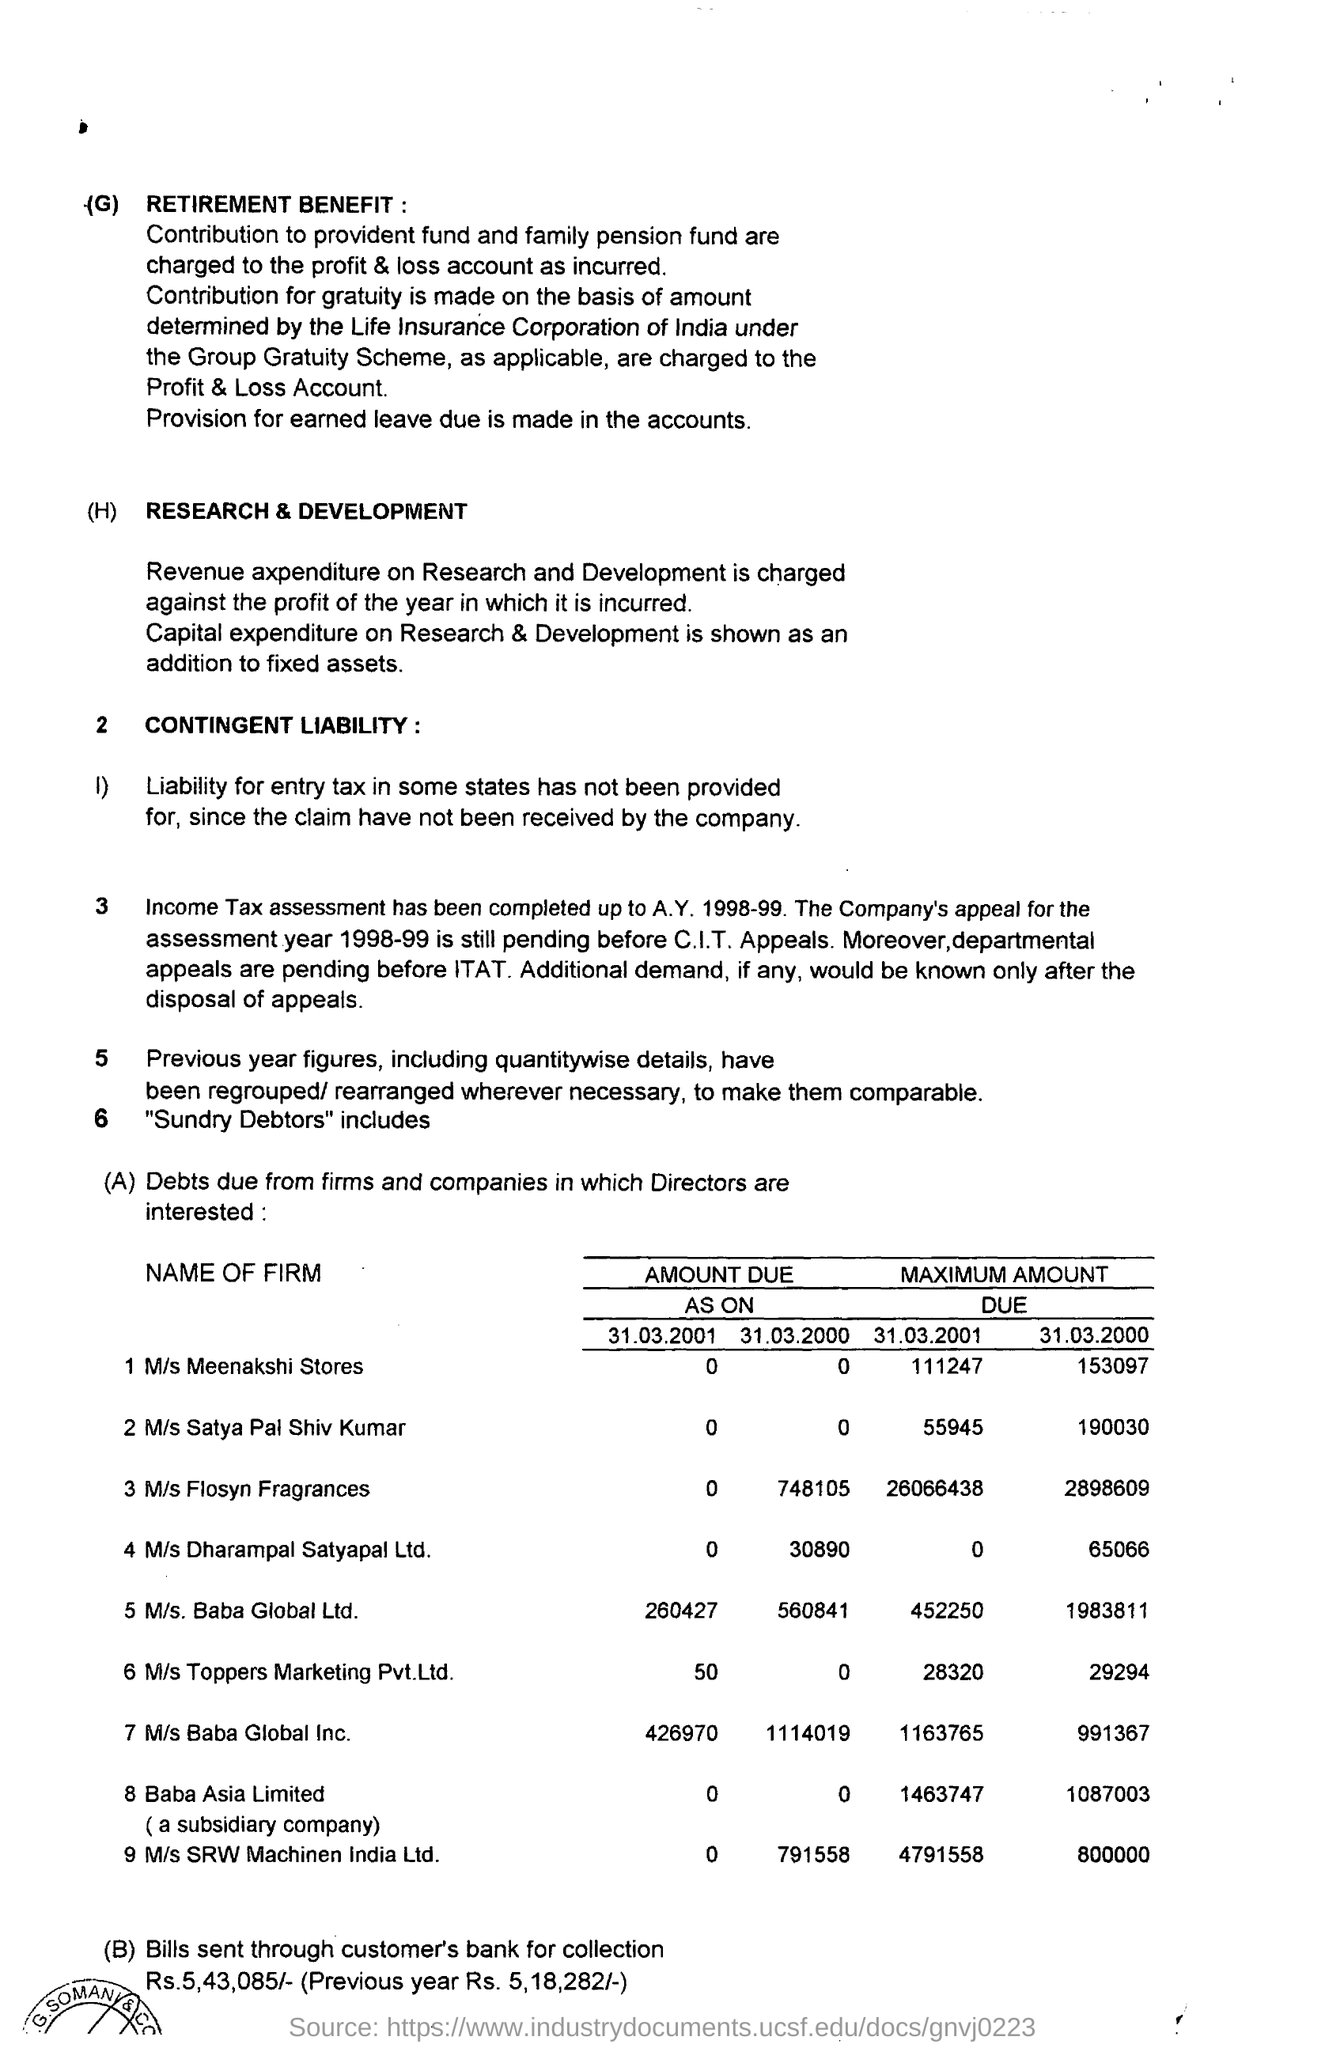Highlight a few significant elements in this photo. The maximum amount due for M/s Meenakshi Stores on March 31, 2001 was Rs. 1,11,247. The maximum amount due for Baba Asia Ltd on March 31, 2001 is 14,637,470. On March 31, 2000, the maximum amount due for M/s Baba Global Ltd was 19,838,111. On March 31, 2000, the maximum amount due for Baba Asia Ltd was 10,870,035. On March 31, 2001, the maximum amount due for M/s Flosyn Fragrances was 26066438... . 